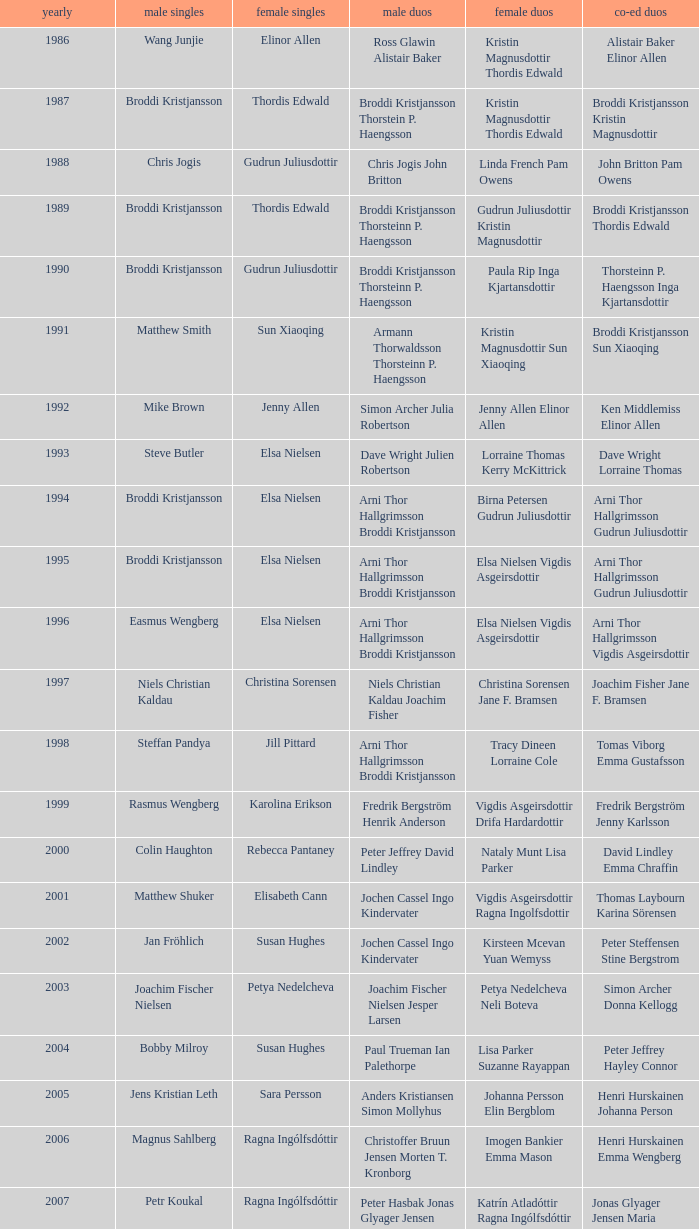In which women's doubles did Wang Junjie play men's singles? Kristin Magnusdottir Thordis Edwald. 